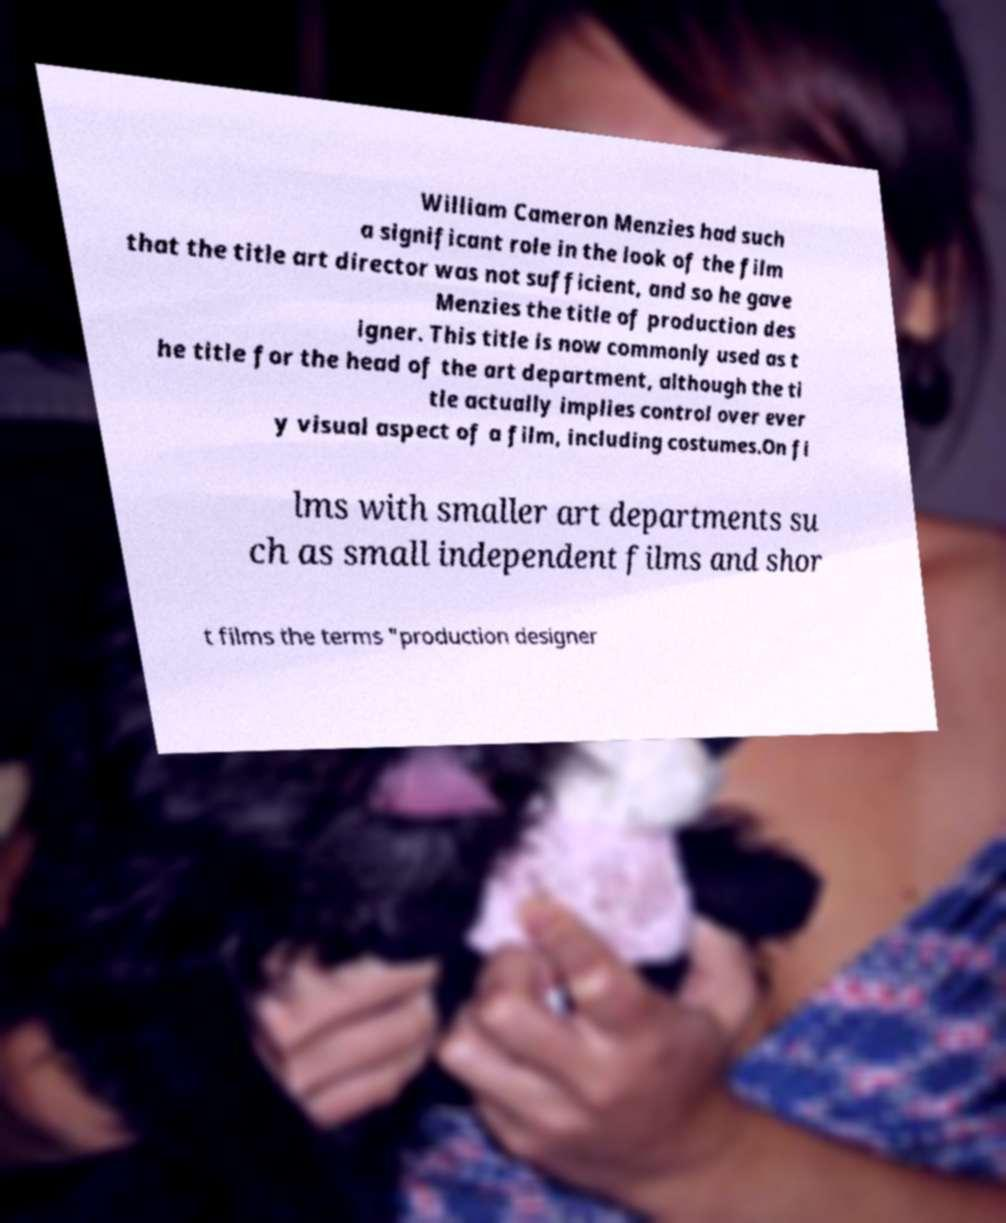I need the written content from this picture converted into text. Can you do that? William Cameron Menzies had such a significant role in the look of the film that the title art director was not sufficient, and so he gave Menzies the title of production des igner. This title is now commonly used as t he title for the head of the art department, although the ti tle actually implies control over ever y visual aspect of a film, including costumes.On fi lms with smaller art departments su ch as small independent films and shor t films the terms "production designer 